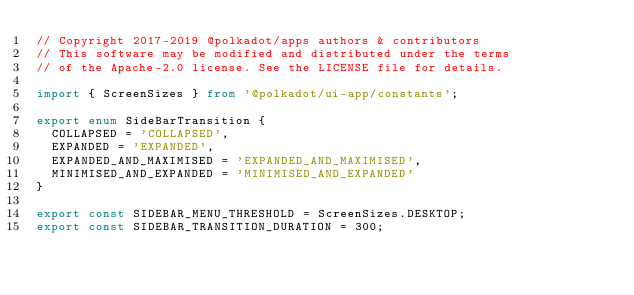<code> <loc_0><loc_0><loc_500><loc_500><_TypeScript_>// Copyright 2017-2019 @polkadot/apps authors & contributors
// This software may be modified and distributed under the terms
// of the Apache-2.0 license. See the LICENSE file for details.

import { ScreenSizes } from '@polkadot/ui-app/constants';

export enum SideBarTransition {
	COLLAPSED = 'COLLAPSED',
	EXPANDED = 'EXPANDED',
	EXPANDED_AND_MAXIMISED = 'EXPANDED_AND_MAXIMISED',
	MINIMISED_AND_EXPANDED = 'MINIMISED_AND_EXPANDED'
}

export const SIDEBAR_MENU_THRESHOLD = ScreenSizes.DESKTOP;
export const SIDEBAR_TRANSITION_DURATION = 300;
</code> 